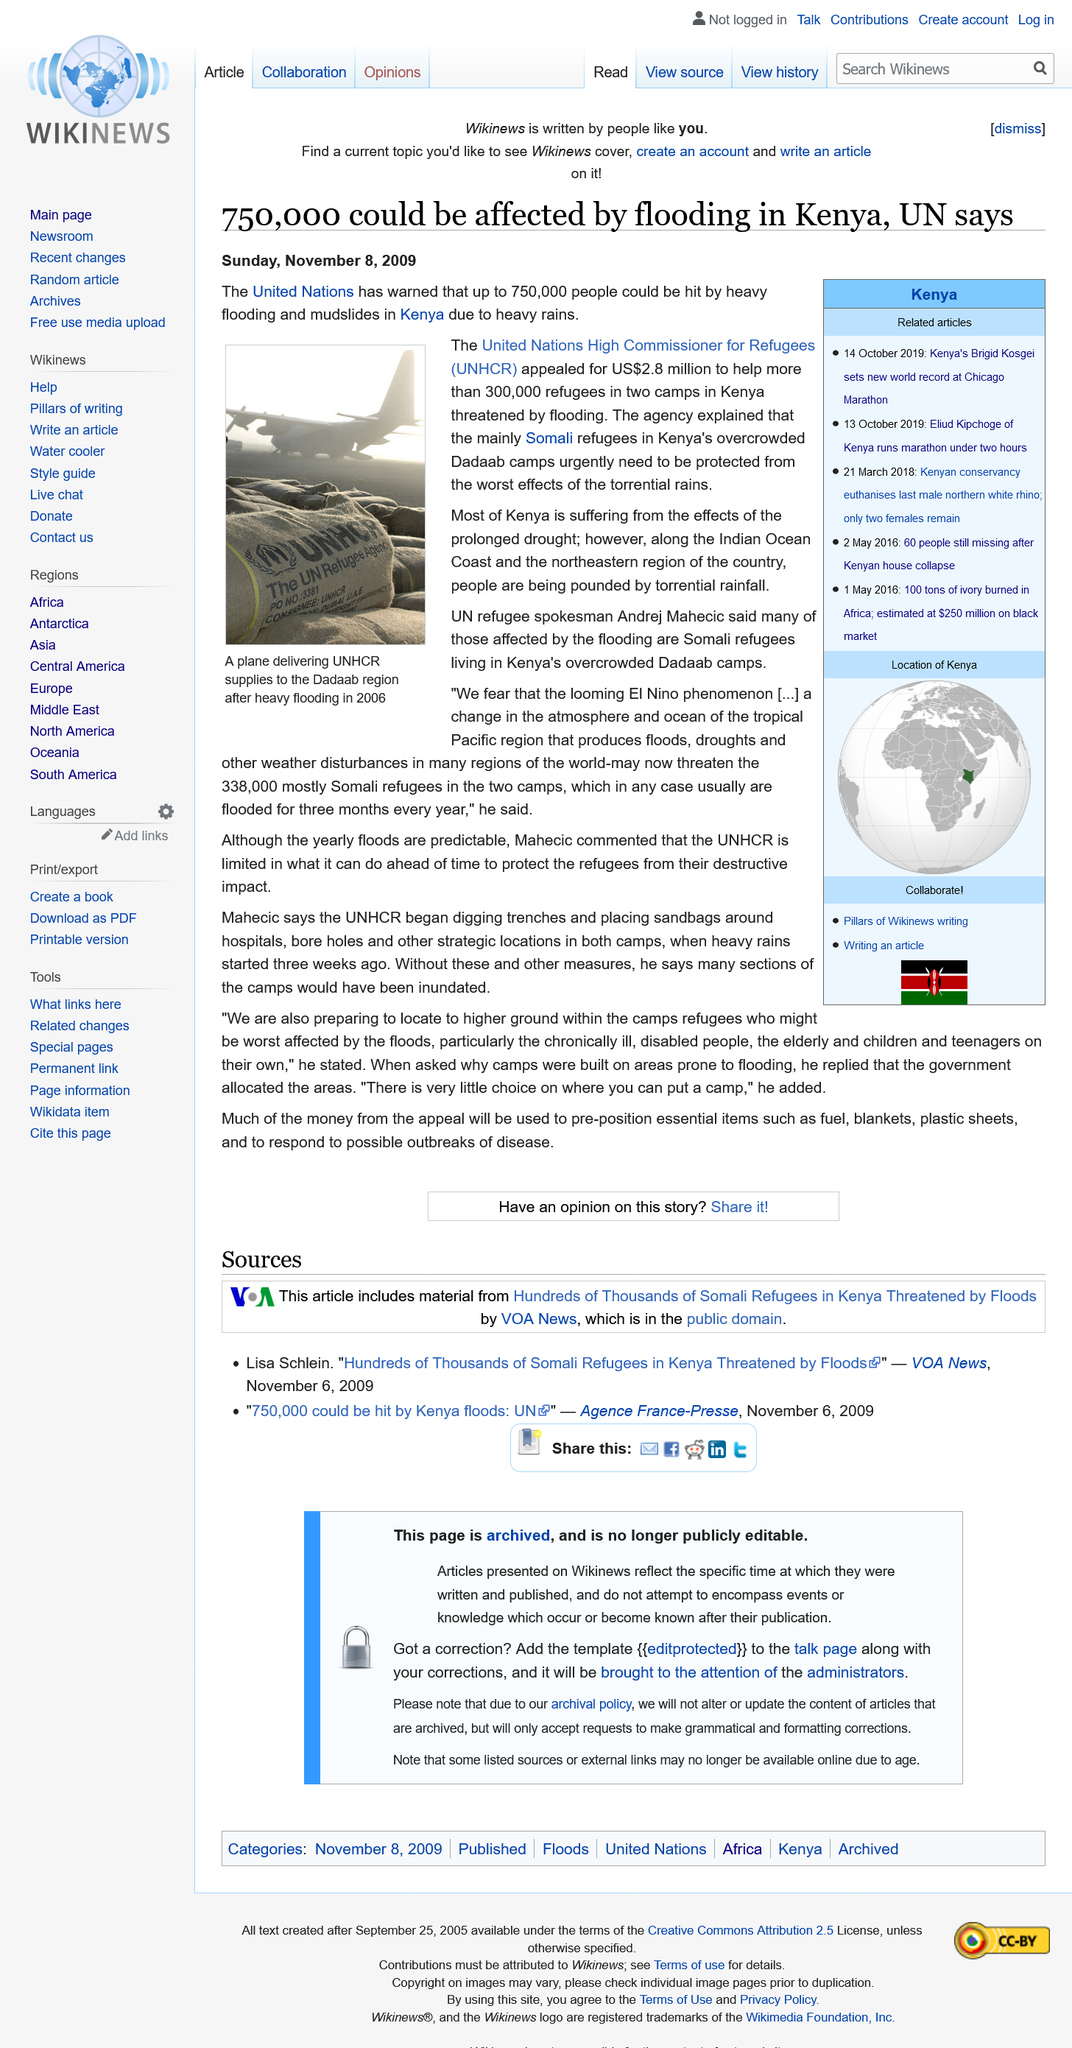Indicate a few pertinent items in this graphic. The depicted image depicts a plane transporting the United Nations High Commissioner for Refugees (UNHCR). It is estimated that approximately 750,000 people in Kenya could be impacted by flooding. The UNHCR appealed for $2.8 million in funding. 